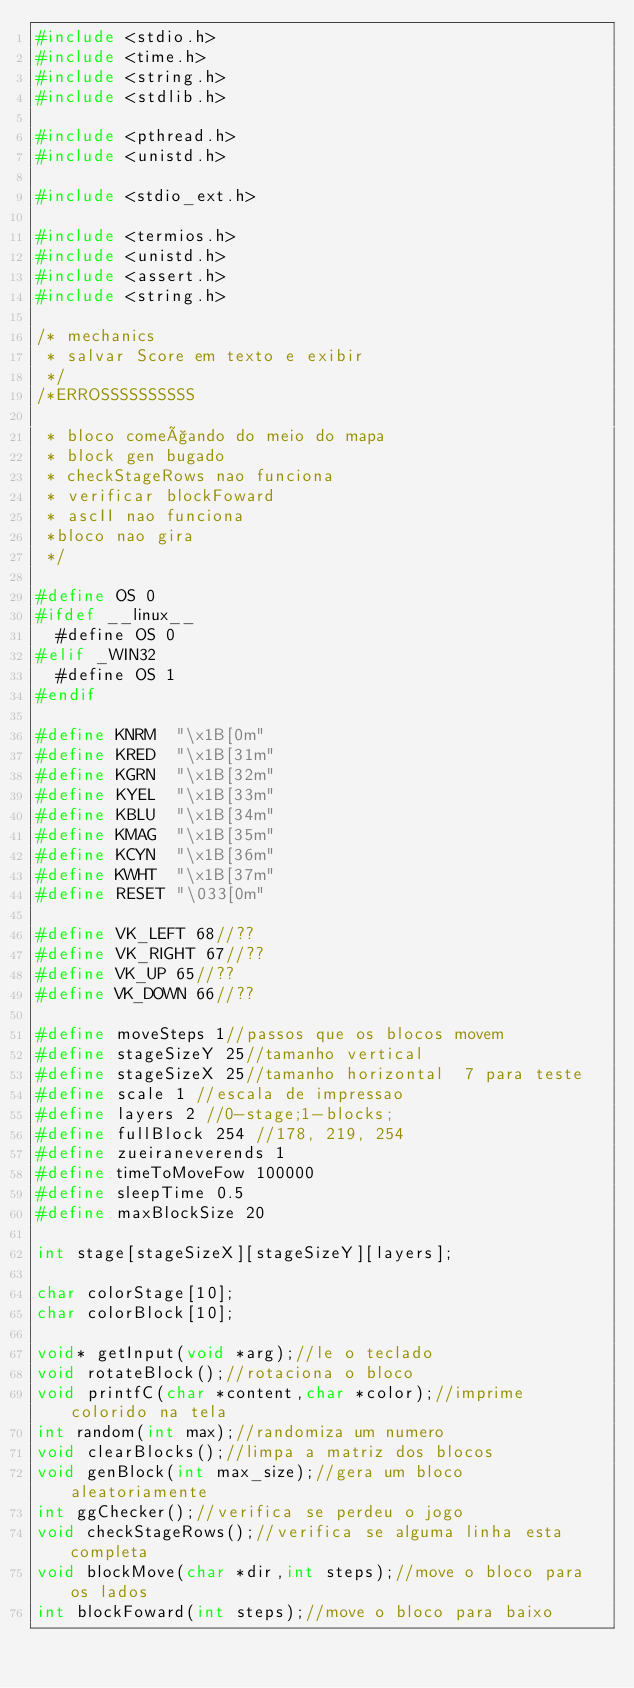<code> <loc_0><loc_0><loc_500><loc_500><_C_>#include <stdio.h>
#include <time.h>
#include <string.h>
#include <stdlib.h>

#include <pthread.h>
#include <unistd.h>

#include <stdio_ext.h>

#include <termios.h>
#include <unistd.h>
#include <assert.h>
#include <string.h>

/* mechanics
 * salvar Score em texto e exibir
 */
/*ERROSSSSSSSSSS
 
 * bloco começando do meio do mapa
 * block gen bugado
 * checkStageRows nao funciona
 * verificar blockFoward
 * ascII nao funciona
 *bloco nao gira
 */

#define OS 0
#ifdef __linux__
	#define OS 0
#elif _WIN32
	#define OS 1
#endif

#define KNRM  "\x1B[0m"
#define KRED  "\x1B[31m"
#define KGRN  "\x1B[32m"
#define KYEL  "\x1B[33m"
#define KBLU  "\x1B[34m"
#define KMAG  "\x1B[35m"
#define KCYN  "\x1B[36m"
#define KWHT  "\x1B[37m"
#define RESET "\033[0m"

#define VK_LEFT 68//??
#define VK_RIGHT 67//??
#define VK_UP 65//??
#define VK_DOWN 66//??

#define moveSteps 1//passos que os blocos movem
#define stageSizeY 25//tamanho vertical
#define stageSizeX 25//tamanho horizontal  7 para teste
#define scale 1 //escala de impressao
#define layers 2 //0-stage;1-blocks;
#define fullBlock 254 //178, 219, 254
#define zueiraneverends 1
#define timeToMoveFow 100000
#define sleepTime 0.5
#define maxBlockSize 20

int stage[stageSizeX][stageSizeY][layers];

char colorStage[10];
char colorBlock[10];

void* getInput(void *arg);//le o teclado
void rotateBlock();//rotaciona o bloco
void printfC(char *content,char *color);//imprime colorido na tela
int random(int max);//randomiza um numero
void clearBlocks();//limpa a matriz dos blocos
void genBlock(int max_size);//gera um bloco aleatoriamente
int ggChecker();//verifica se perdeu o jogo
void checkStageRows();//verifica se alguma linha esta completa
void blockMove(char *dir,int steps);//move o bloco para os lados
int blockFoward(int steps);//move o bloco para baixo</code> 